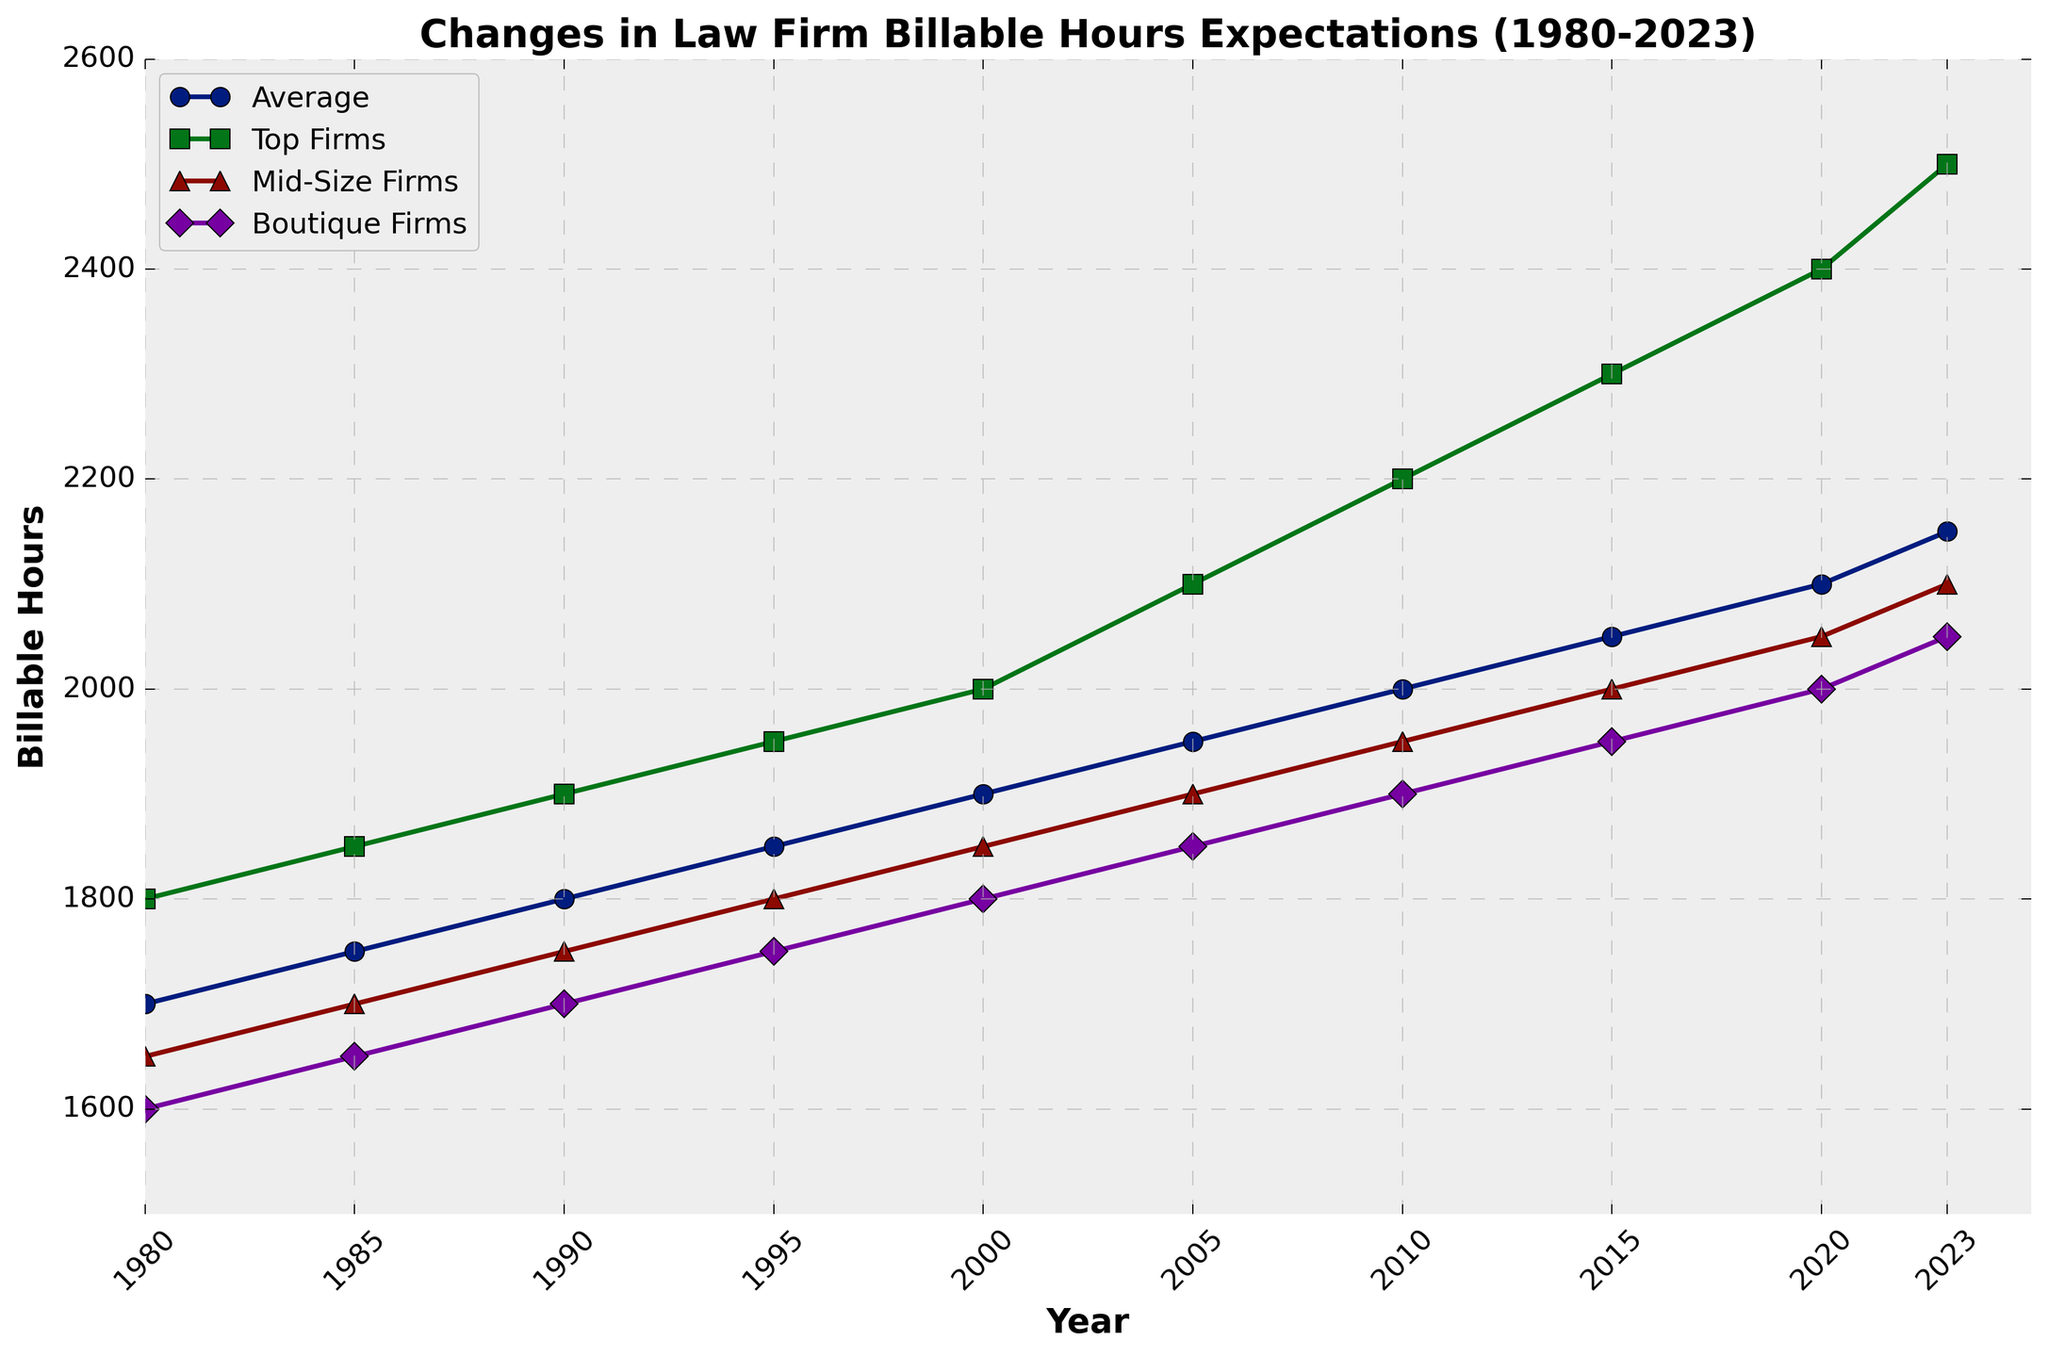Which firm type has the highest billable hours expectation in 2023? To answer this, look at the points representing 2023 on the plot for each firm type. The top firms have the highest point at 2500.
Answer: Top Firms What is the total increase in average billable hours from 1980 to 2023? Find the difference between the average billable hours in 1980 and 2023. This is calculated as 2150 - 1700 = 450.
Answer: 450 In which year do mid-size firms' billable hours expectations surpass 2000? Check the Mid-Size Firms' line and identify the first year it crosses the 2000 mark. It happens between 2010 and 2015, so the year is 2015.
Answer: 2015 How much higher are top firms' billable hours expectations compared to boutique firms' expectations in 2020? Compare the points for top firms (2400) and boutique firms (2000) in 2020. The difference is 2400 - 2000 = 400.
Answer: 400 Which firm type showed the smallest increase in billable hours expectation from 1980 to 2023? Calculate the increases for each firm type and compare them. Boutique Firms: 450, Mid-Size Firms: 450, Top Firms: 700. The smallest increase is 450, which is shared by Boutique and Mid-Size Firms.
Answer: Boutique Firms, Mid-Size Firms In what year do top firms' billable hours expectations first reach 2100? Look at the Top Firms' line and find when it first crosses 2100. It happens in 2005.
Answer: 2005 By how much did the average billable hours increase between 1990 and 2000? Find the difference in the average billable hours between 1990 (1800) and 2000 (1900). The difference is 1900 - 1800 = 100.
Answer: 100 In which year do the lines for the average and mid-size firms' billable hours expectations converge? Identify the year when both lines nearly overlap. This happens in 1990, where both average and mid-size firms' expectations are very close (1800 and 1750 respectively).
Answer: 1990 Did any firm's billable hours expectations decrease at any time between 1980 and 2023? Scan through each firm's line from 1980 to 2023 and see if there is any dip. None of the lines show a decrease.
Answer: No What is the difference between the highest and lowest billable hours expectation values across all firm types and years? The highest value is 2500 (Top Firms in 2023), and the lowest is 1600 (Boutique Firms in 1980). The difference is 2500 - 1600 = 900.
Answer: 900 